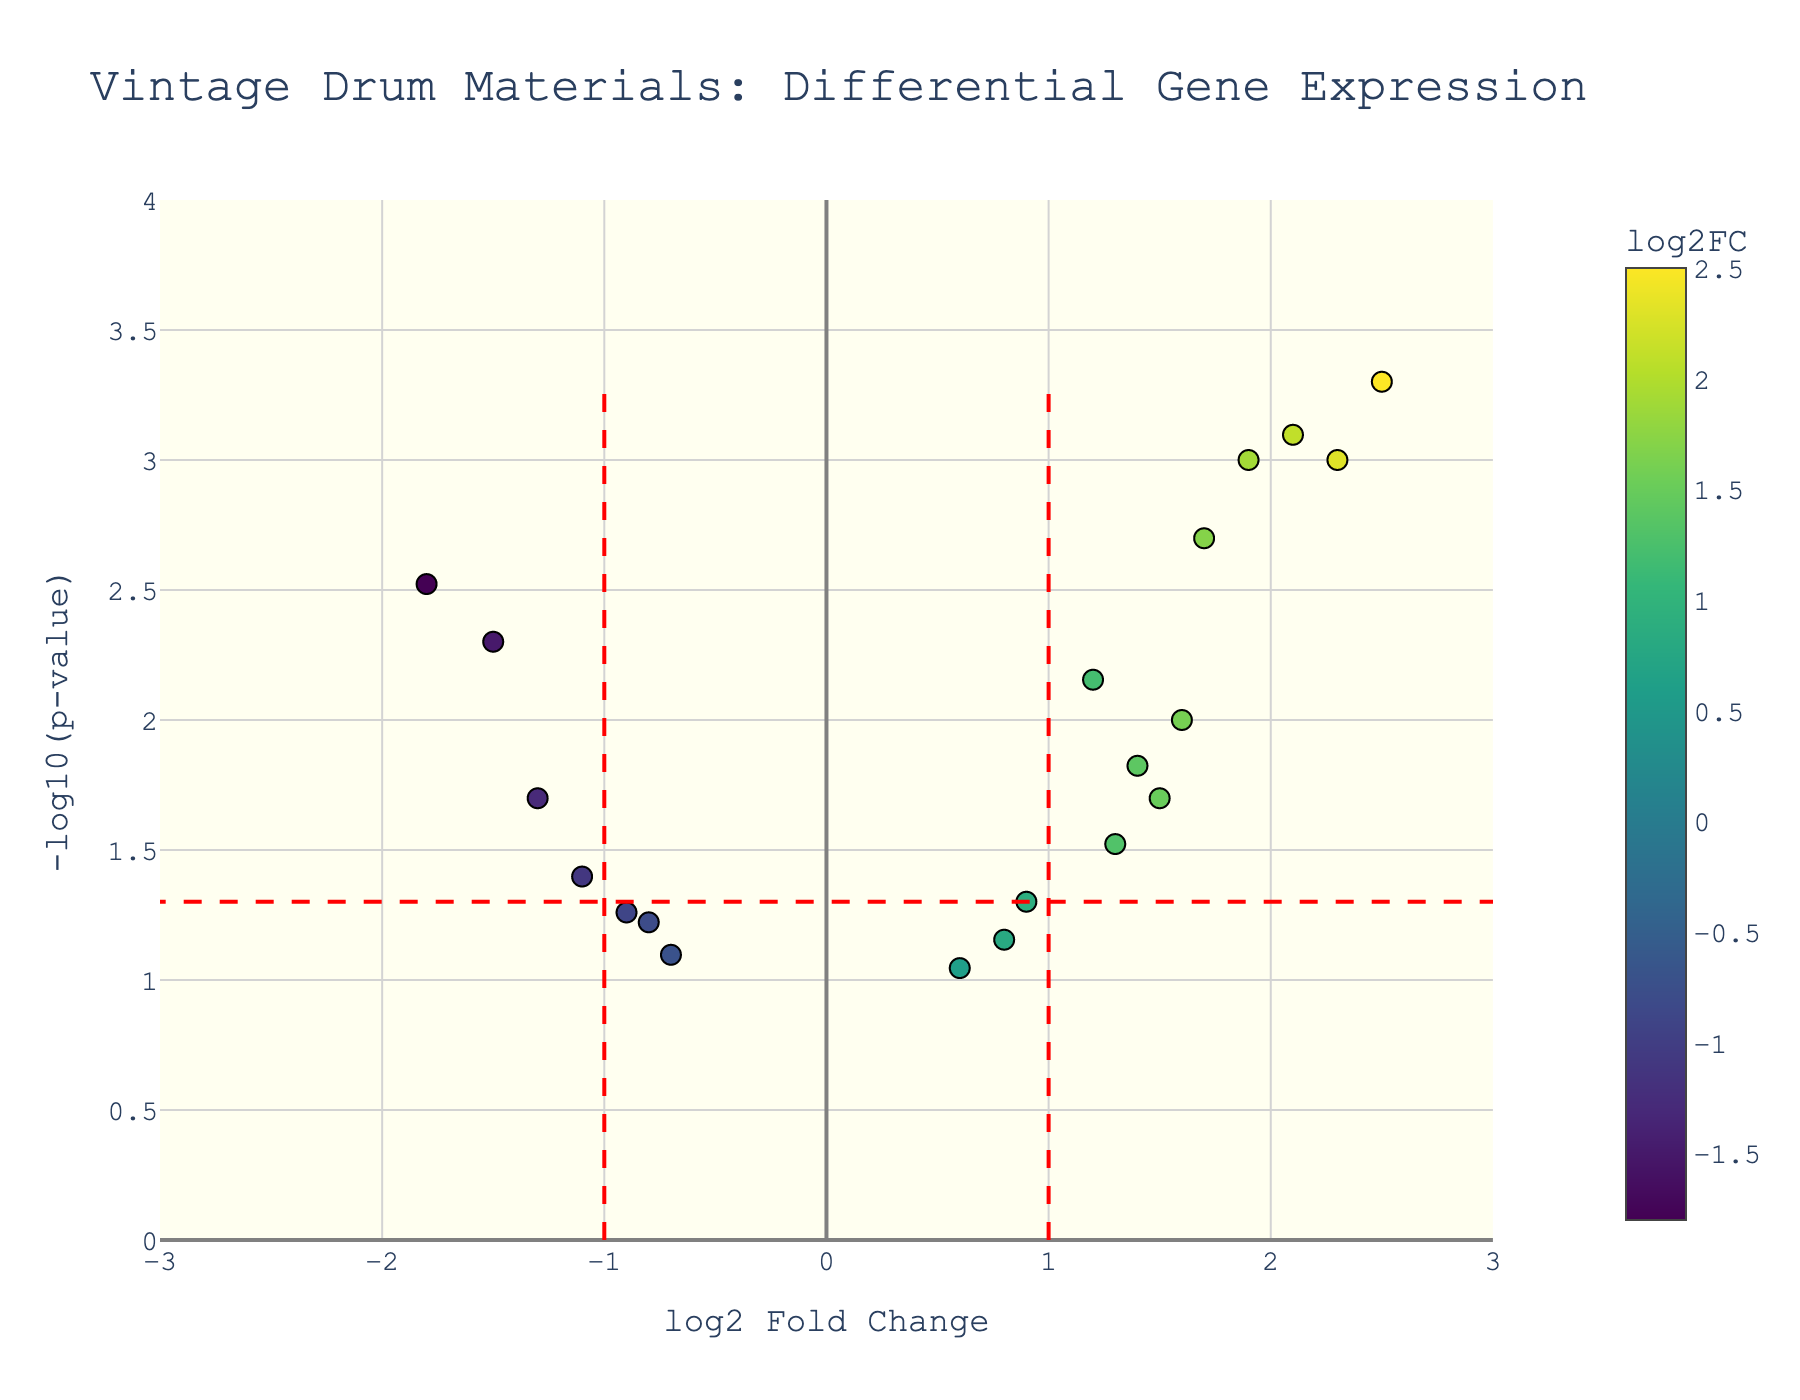What's the title of the volcano plot? The title of the plot is located at the upper part of the figure and typically describes the content of the chart in a concise manner. For this plot, it is "Vintage Drum Materials: Differential Gene Expression."
Answer: Vintage Drum Materials: Differential Gene Expression How many data points fall outside the threshold lines for significant log2 fold change? The threshold lines for significant log2 fold change are positioned at log2FC = -1 and log2FC = 1. We need to count the points that lie either to the left of -1 or the right of 1 on the x-axis. Observing the figure, there are 7 points outside this threshold.
Answer: 7 Which vintage drum material has the highest negative log2 fold change? To find the material with the highest negative log2 fold change, look for the point with the lowest x-axis value. In this plot, "Birch_sustain" at approximately -1.8 is the point with the highest negative log2 fold change.
Answer: Birch_sustain What is the p-value threshold marked in the plot? The p-value threshold is marked by a horizontal red dashed line. To find this value, look at the y-axis where this line intersects. For this figure, it intersects at -log10(p-value) which corresponds to a p-value of 0.05.
Answer: 0.05 What are the log2 fold change and p-value range for this plot? The ranges can be determined by looking at the x-axis and y-axis. The log2 fold change on the x-axis ranges from -3 to 3, and the -log10(p-value) on the y-axis ranges from 0 to 4.
Answer: log2FC: -3 to 3, p-value: 0 to 4 Which vintage drum material has the lowest p-value, and what is its log2 fold change? To find this, look for the point with the highest y-axis value. The corresponding vintage drum material is "Slingerland_Radio_King_wood" with a log2 fold change of 2.5.
Answer: Slingerland_Radio_King_wood, 2.5 How many vintage drum materials have a log2 fold change greater than 2? To find this, count the number of points to the right of the vertical line at log2 fold change of 2. There are 3 points in this region.
Answer: 3 Which vintage drum material is closest to the threshold for p-value significance but just above the threshold? Look for the point just above the horizontal threshold line at -log10(p-value). "Beech_attack" with log2FC of 0.9 and p-value just around 0.05 fits this description.
Answer: Beech_attack What is the log2 fold change of "Maple_resonance" and how significant is its p-value? To find this, look for the hover text associated with "Maple_resonance". According to the plot, "Maple_resonance" has a log2 fold change of 2.3 and a p-value of 0.001.
Answer: 2.3, 0.001 How does the log2 fold change of "Hickory_attack" compare to "Rosewood_overtones"? "Hickory_attack" has a log2 fold change of 1.3, and "Rosewood_overtones" has a log2 fold change of 1.2. Hence, "Hickory_attack" has a slightly higher log2 fold change.
Answer: Hickory_attack > Rosewood_overtones 